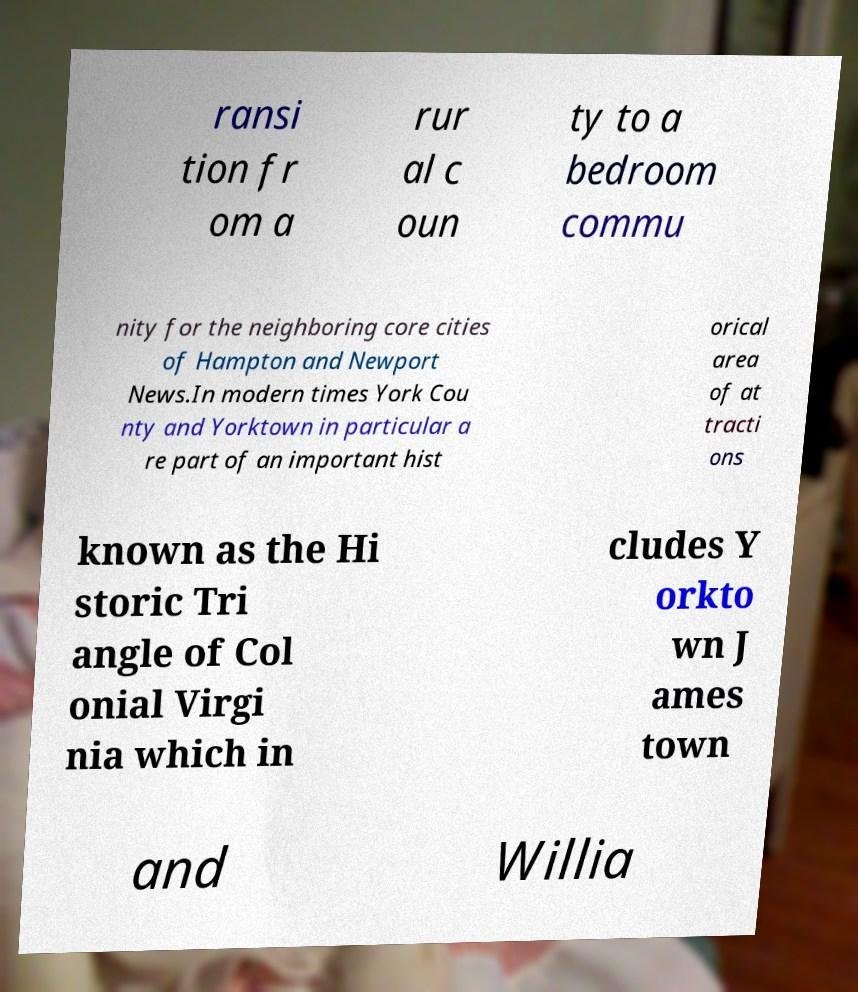There's text embedded in this image that I need extracted. Can you transcribe it verbatim? ransi tion fr om a rur al c oun ty to a bedroom commu nity for the neighboring core cities of Hampton and Newport News.In modern times York Cou nty and Yorktown in particular a re part of an important hist orical area of at tracti ons known as the Hi storic Tri angle of Col onial Virgi nia which in cludes Y orkto wn J ames town and Willia 